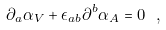Convert formula to latex. <formula><loc_0><loc_0><loc_500><loc_500>\partial _ { a } \alpha _ { V } + \epsilon _ { a b } \partial ^ { b } \alpha _ { A } = 0 \ ,</formula> 